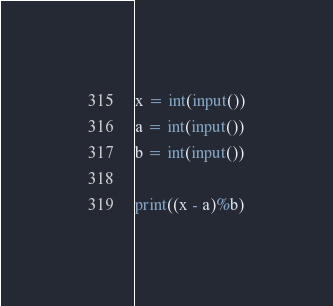<code> <loc_0><loc_0><loc_500><loc_500><_Python_>x = int(input())
a = int(input())
b = int(input())

print((x - a)%b)
</code> 